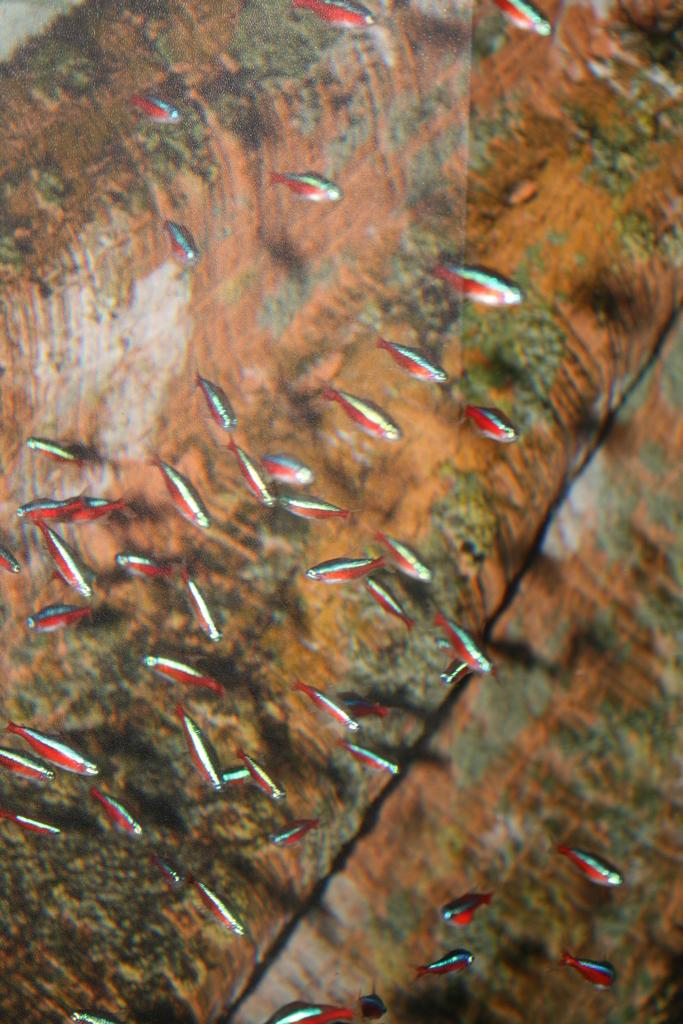What type of animals can be seen in the image? There are fish in the water. What is visible in the background of the image? There is an object visible in the background of the image. What type of desk can be seen in the image? There is no desk present in the image; it features fish in the water and an object in the background. 